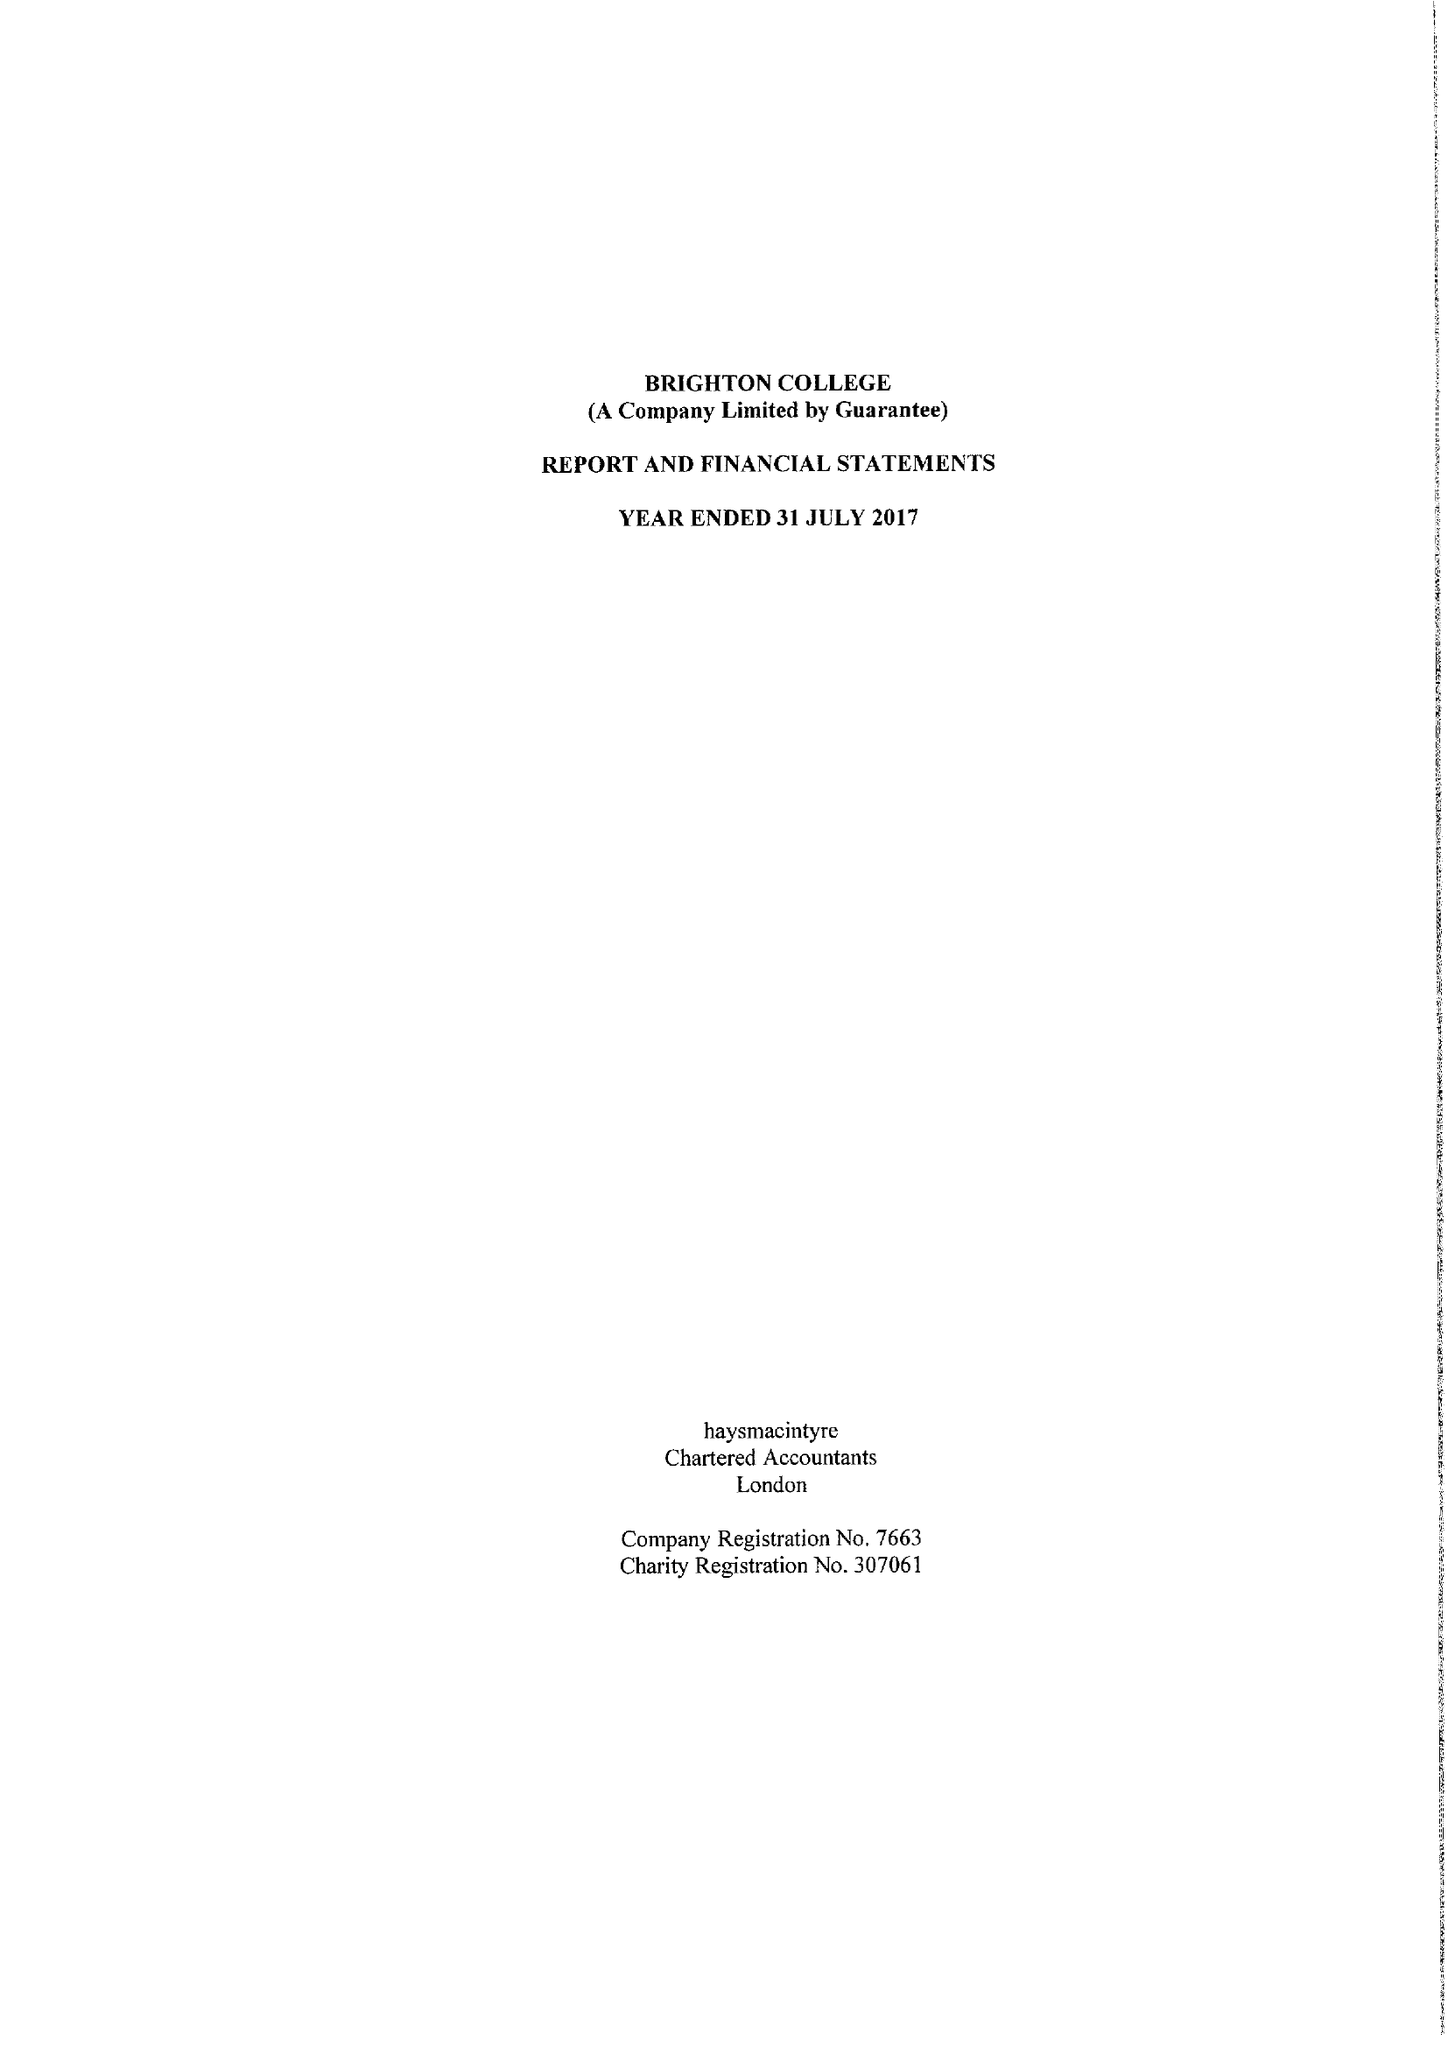What is the value for the address__street_line?
Answer the question using a single word or phrase. EASTERN ROAD 